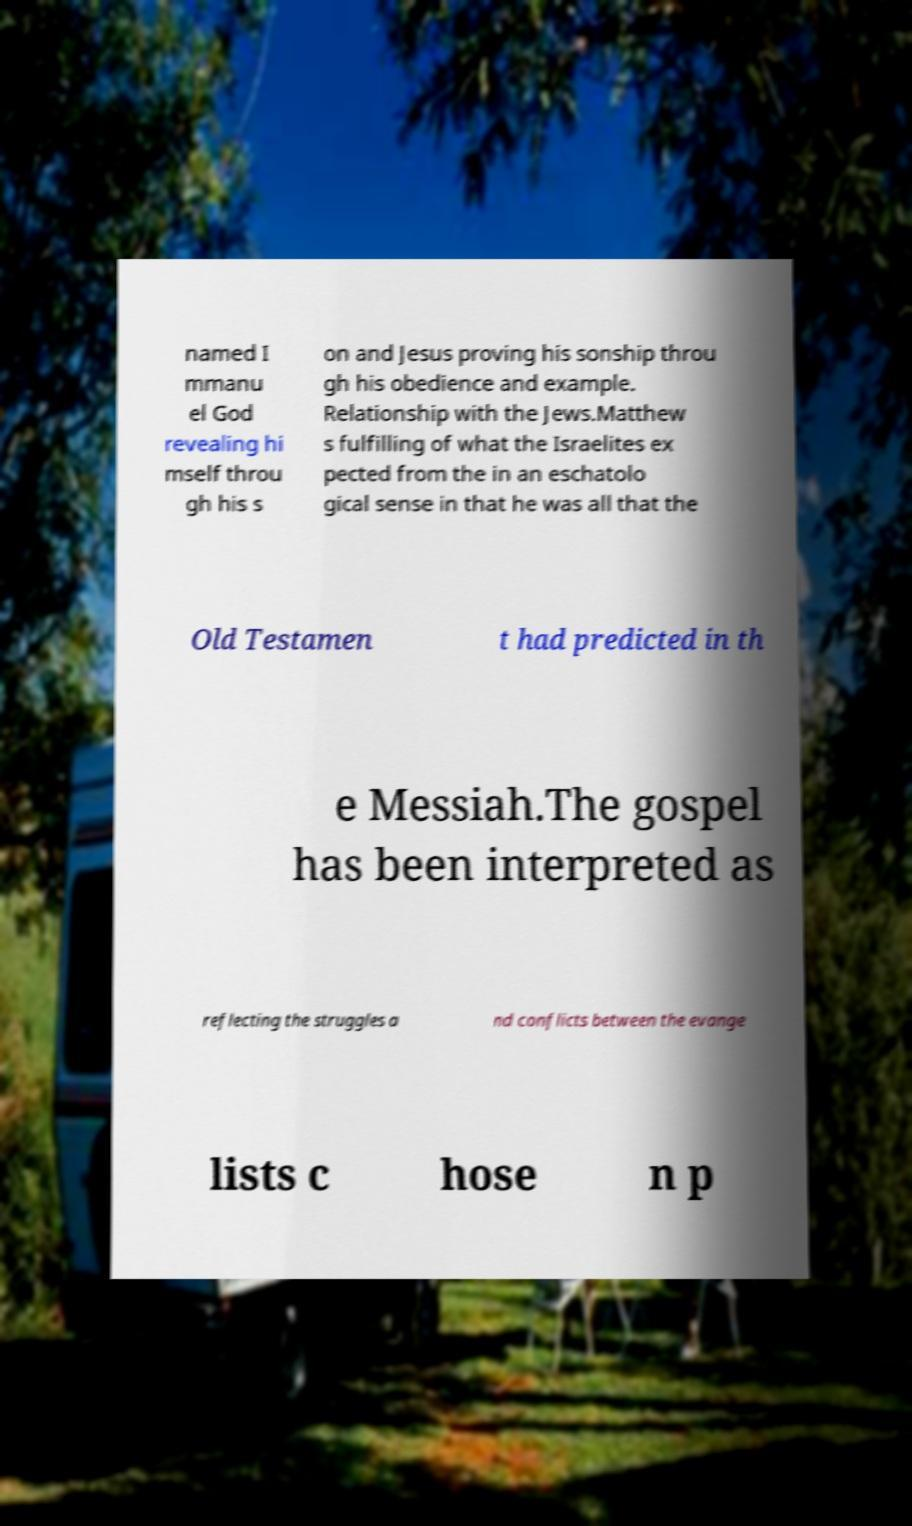Please read and relay the text visible in this image. What does it say? named I mmanu el God revealing hi mself throu gh his s on and Jesus proving his sonship throu gh his obedience and example. Relationship with the Jews.Matthew s fulfilling of what the Israelites ex pected from the in an eschatolo gical sense in that he was all that the Old Testamen t had predicted in th e Messiah.The gospel has been interpreted as reflecting the struggles a nd conflicts between the evange lists c hose n p 